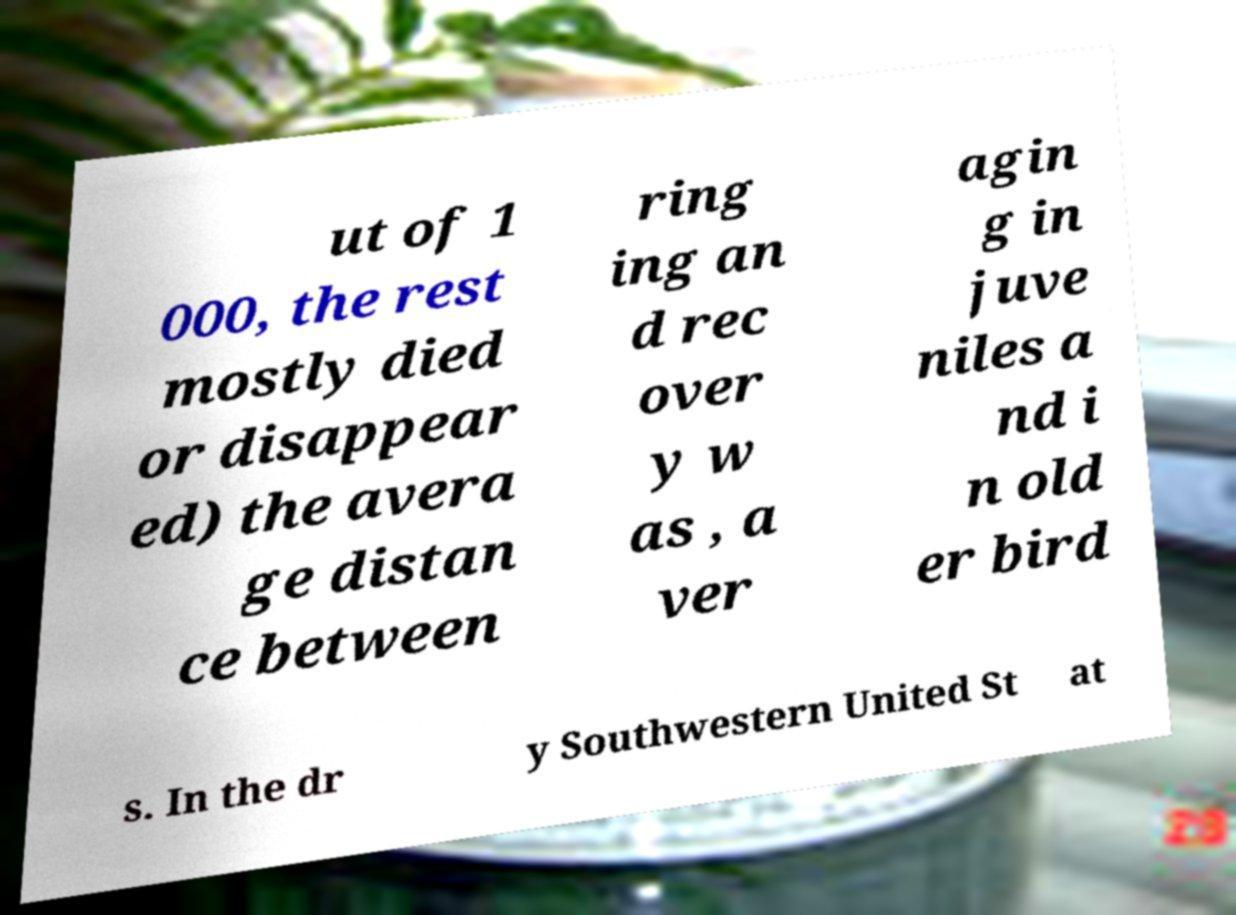Can you accurately transcribe the text from the provided image for me? ut of 1 000, the rest mostly died or disappear ed) the avera ge distan ce between ring ing an d rec over y w as , a ver agin g in juve niles a nd i n old er bird s. In the dr y Southwestern United St at 